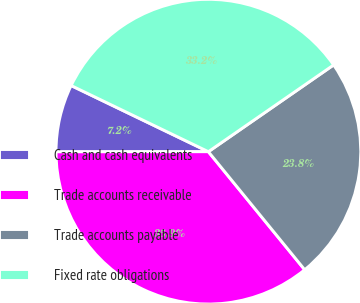Convert chart to OTSL. <chart><loc_0><loc_0><loc_500><loc_500><pie_chart><fcel>Cash and cash equivalents<fcel>Trade accounts receivable<fcel>Trade accounts payable<fcel>Fixed rate obligations<nl><fcel>7.16%<fcel>35.88%<fcel>23.75%<fcel>33.21%<nl></chart> 